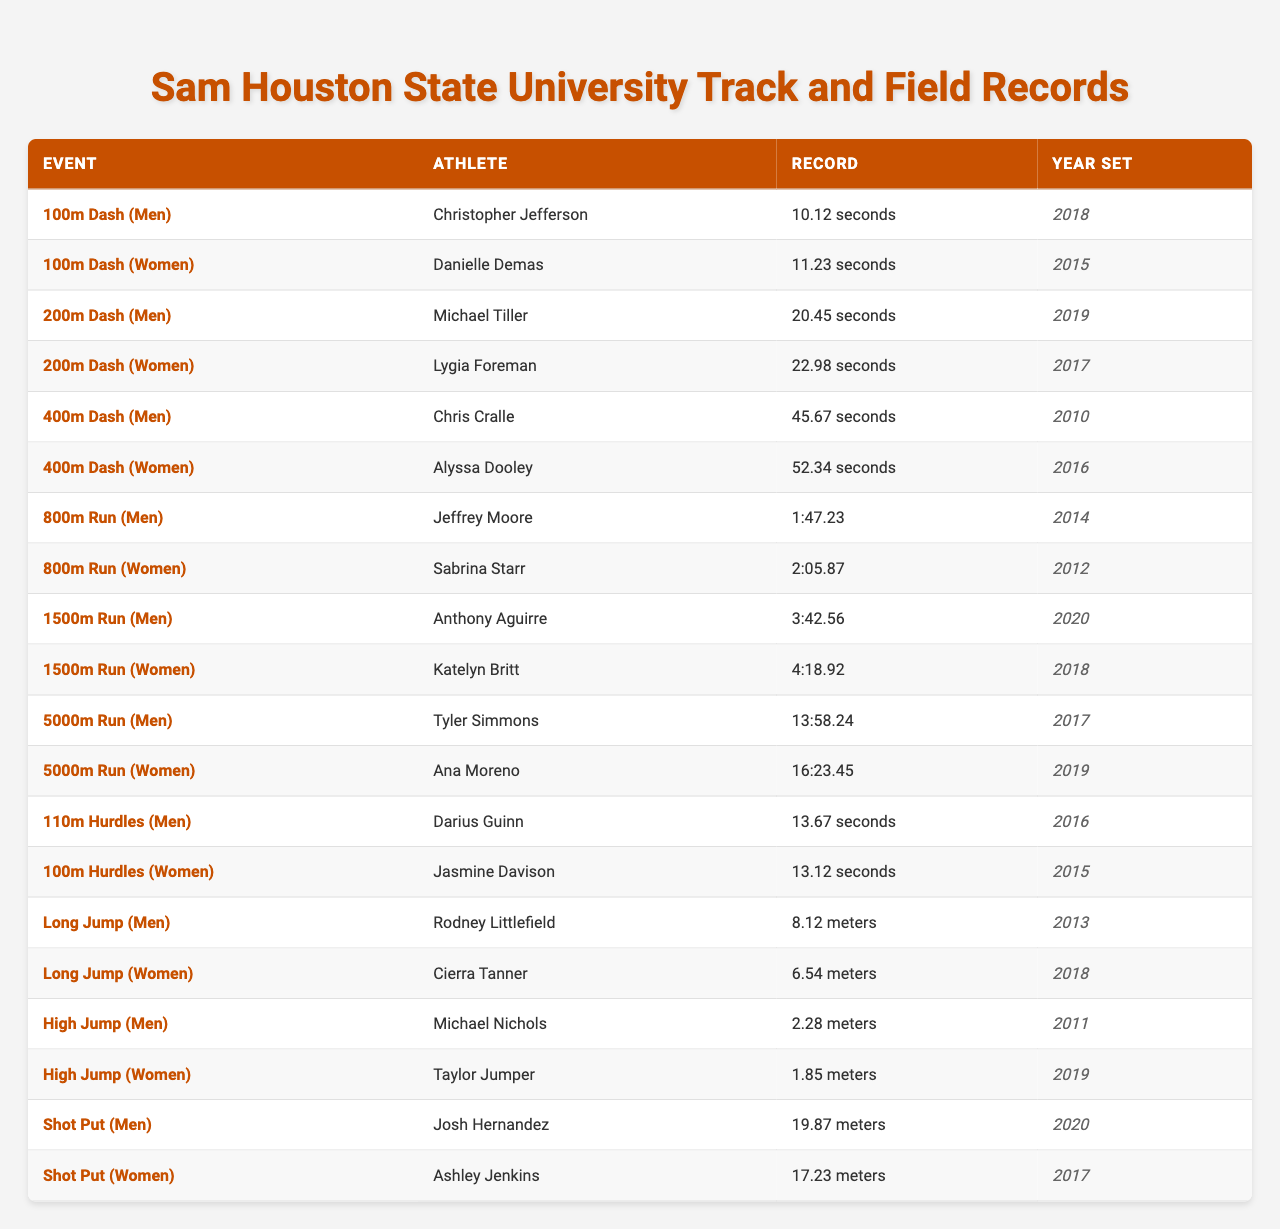What is the record for the men's 100m dash? The table shows that Christopher Jefferson holds the record for the men's 100m dash with a time of 10.12 seconds, which was set in 2018.
Answer: 10.12 seconds Who set the women's 400m dash record, and what year was it set? According to the table, the women's 400m dash record was set by Alyssa Dooley in 2016.
Answer: Alyssa Dooley, 2016 Which athlete holds the record for the men's long jump? The table indicates that Rodney Littlefield holds the record for the men's long jump with a distance of 8.12 meters, which was achieved in 2013.
Answer: Rodney Littlefield, 8.12 meters What is the fastest record for the women's 100m hurdles? The table shows that Jasmine Davison holds the women's 100m hurdles record at a time of 13.12 seconds, set in 2015.
Answer: 13.12 seconds Which event has the highest recorded distance for men? To find this, we look for the maximum distance in the 'Record' column for men. The men's shot put record is 19.87 meters, which is greater than any other men's event listed.
Answer: Shot Put, 19.87 meters Is the women's 1500m run record faster than the women’s 800m run record? The 1500m run record is 4:18.92 and the 800m run record is 2:05.87. When comparing the times, 4:18.92 is over 4 minutes, while 2:05.87 is about 2 minutes. Therefore, the women's 800m run record is faster than the 1500m run record.
Answer: Yes Who set the men's 5000m run record, and how does it compare to the women's 5000m record? Tyler Simmons set the men's 5000m run record at 13:58.24, while Ana Moreno set the women's record at 16:23.45. The men's time is under 14 minutes, while the women's time is over 16 minutes, indicating that the men's record is faster.
Answer: Tyler Simmons, faster than women's record Which year saw the highest number of records set? By examining the table, we see multiple records were set in different years, but only 2018 has 3 records (Men's 100m, Men's 1500m, Women's high jump), which is the highest for a single year.
Answer: 2018 What is the average time for the men's races listed? The men's events in the table include the 100m dash, 200m dash, 400m dash, 800m run, 1500m run, 5000m run, 110m hurdles, and long jump. Converting times to seconds for averaging: 10.12, 20.45, 45.67, 107.23, 222.56, 838.24, 13.67. The sum is 1454.44 seconds and there are 7 events, yielding an average of 1454.44/7 ≈ 207.77 seconds.
Answer: 207.77 seconds Which athlete has the longest record set among all events? Examining the data, the longest record among the events is in the men's shot put, where Josh Hernandez recorded a distance of 19.87 meters in 2020, which is longer than any other listed records.
Answer: Josh Hernandez, 19.87 meters 